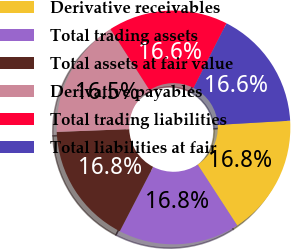<chart> <loc_0><loc_0><loc_500><loc_500><pie_chart><fcel>Derivative receivables<fcel>Total trading assets<fcel>Total assets at fair value<fcel>Derivative payables<fcel>Total trading liabilities<fcel>Total liabilities at fair<nl><fcel>16.75%<fcel>16.77%<fcel>16.79%<fcel>16.54%<fcel>16.56%<fcel>16.58%<nl></chart> 